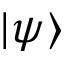Convert formula to latex. <formula><loc_0><loc_0><loc_500><loc_500>| \psi \rangle</formula> 